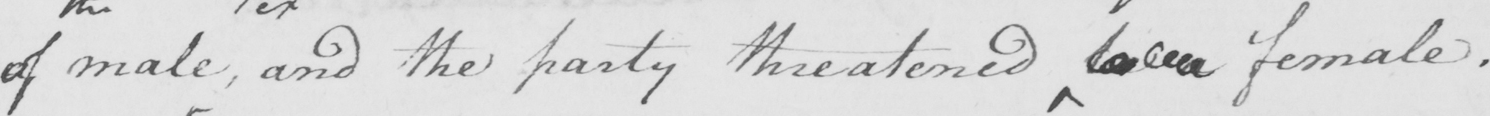Can you tell me what this handwritten text says? of male  , and the party threatened be a female . 